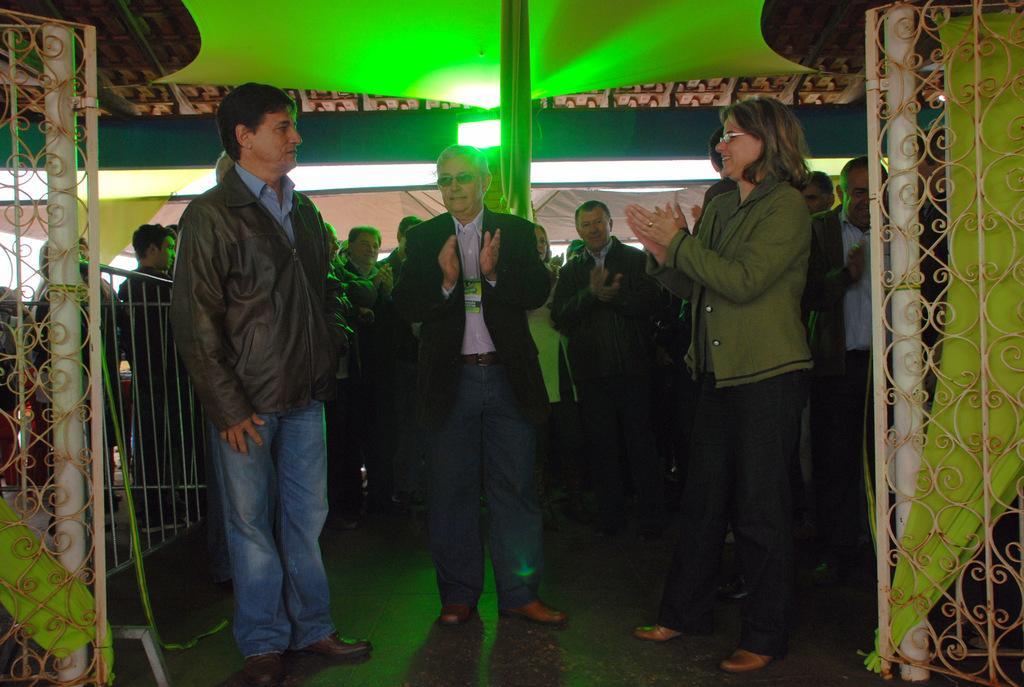Can you describe this image briefly? In this image we can see people standing on the floor and clapping their hands. In the background there are electric lights, curtain and a gate. 